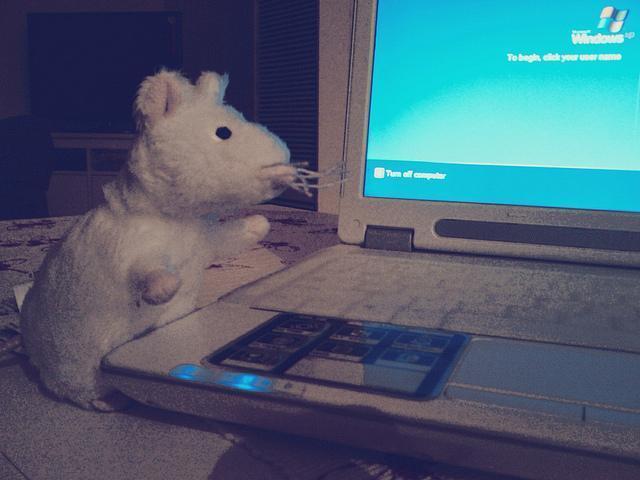Does the image validate the caption "The tv is below the teddy bear."?
Answer yes or no. No. 